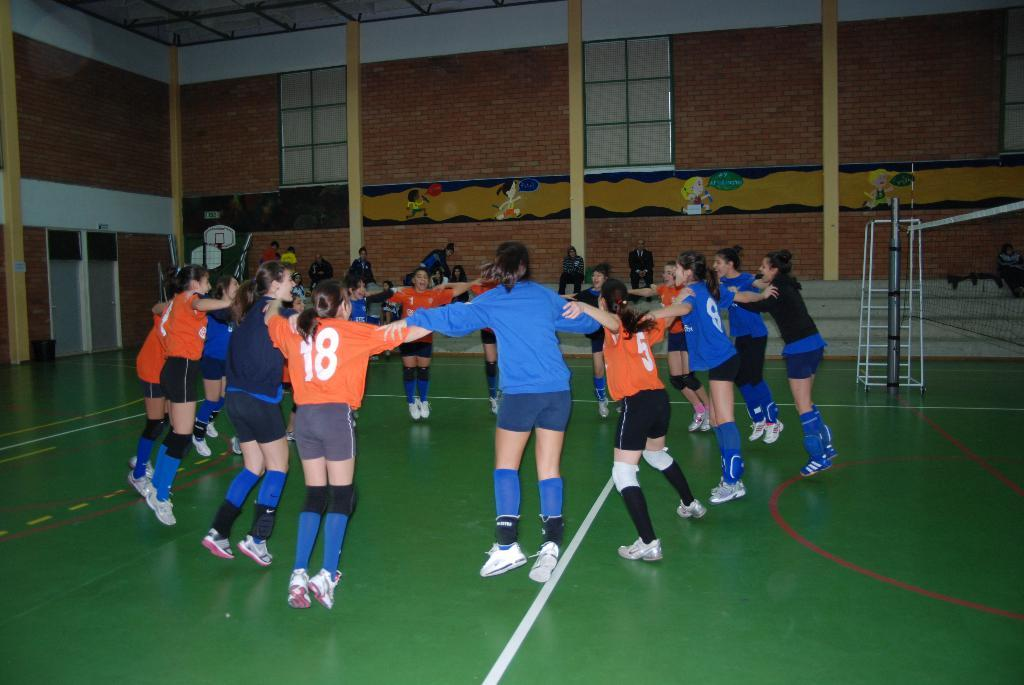Provide a one-sentence caption for the provided image. a person with an orange shirt that has the number 18 on it. 